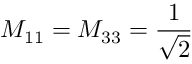<formula> <loc_0><loc_0><loc_500><loc_500>M _ { 1 1 } = M _ { 3 3 } = \frac { 1 } { \sqrt { 2 } }</formula> 